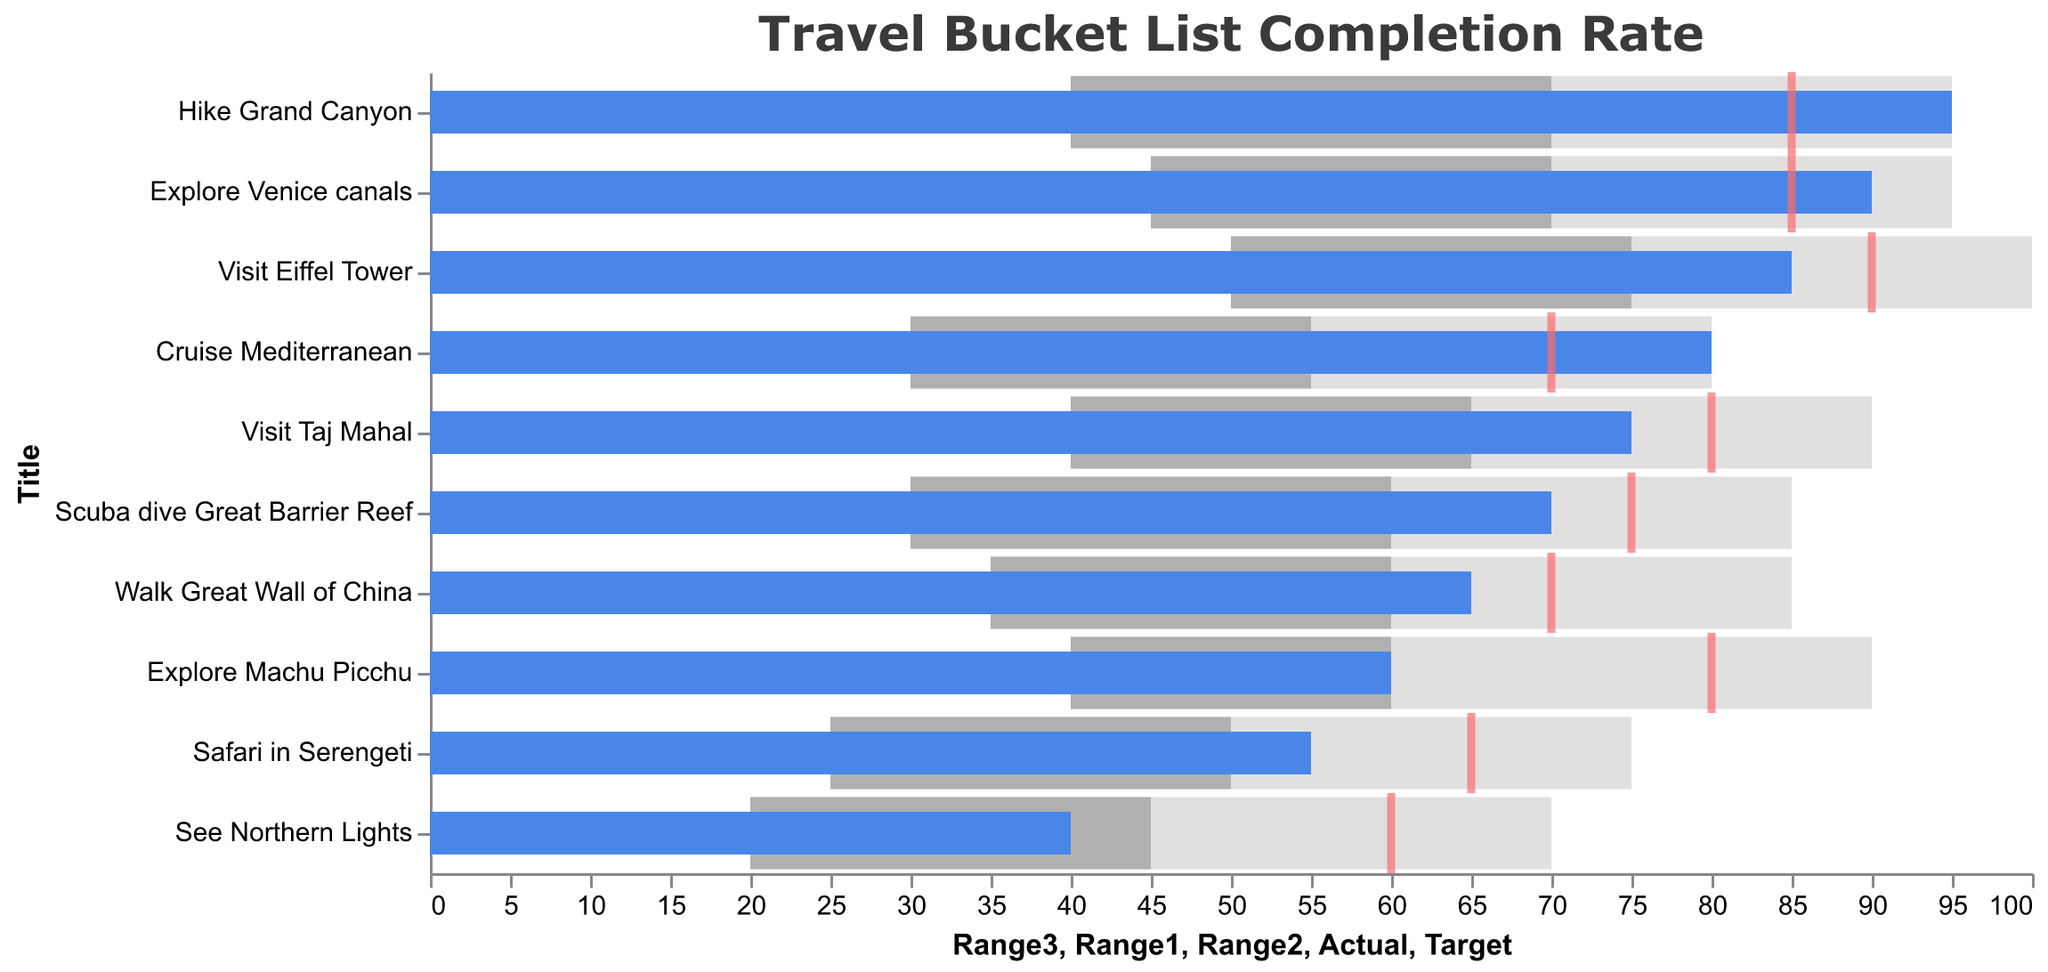Which travel bucket list item has the highest completion rate? The highest completion rate is indicated by the "Actual" bar that extends the furthest to the right. In this case, it is the "Hike Grand Canyon" with an "Actual" value of 95.
Answer: Hike Grand Canyon What is the target completion rate for "Visit Eiffel Tower"? The target completion rate is indicated by the red tick mark for each item. For the "Visit Eiffel Tower," the red tick is at the 90 mark.
Answer: 90 How many travel experiences have a completion rate above 80? Check the "Actual" values for each travel experience and count how many exceed 80. "Visit Eiffel Tower" (85), "Hike Grand Canyon" (95), "Cruise Mediterranean" (80), and "Explore Venice canals" (90) all exceed 80, totaling four items.
Answer: 4 Which travel goal has an actual completion rate that surpasses its target by the largest amount? Calculate the difference between the "Actual" and "Target" for each item. "Hike Grand Canyon" has a difference of 95 - 85 = 10. "Cruise Mediterranean" has a difference of 80 - 70 = 10. Both have the largest differences.
Answer: Hike Grand Canyon and Cruise Mediterranean What is the range of completion considered as good for "Explore Machu Picchu"? The good range for each item is represented by the second color bar. For "Explore Machu Picchu," it ranges from 40 to 60.
Answer: 40-60 Which travel item has the lowest completion rate relative to its target rate? Calculate the percentage of the "Actual" value relative to the "Target" value for each item. "See Northern Lights" has an "Actual" of 40 and a "Target" of 60, which is (40/60)*100 = 66.67%. This is the lowest relative completion rate.
Answer: See Northern Lights Are there any travel experiences where the completion rate met the highest range? Check if the "Actual" values hit the upper bound of the highest (third) range. "Hike Grand Canyon" has an "Actual" value equal to its third range of 95, indicating it met the highest range.
Answer: Hike Grand Canyon How many items have a target completion rate of 70? Count how many red ticks (Targets) are at the 70 mark. "Cruise Mediterranean" and "Walk Great Wall of China" each have a target completion of 70.
Answer: 2 